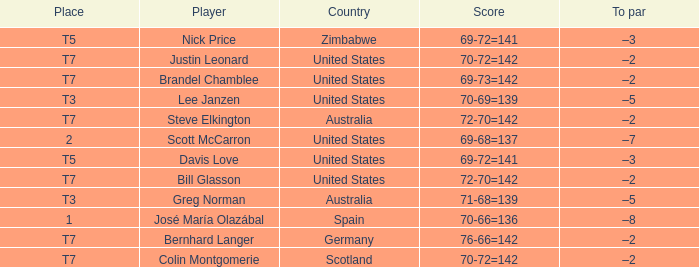Name the Player who has a To par of –2 and a Score of 69-73=142? Brandel Chamblee. 